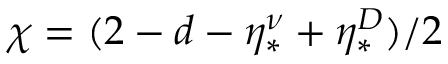Convert formula to latex. <formula><loc_0><loc_0><loc_500><loc_500>\chi = ( 2 - d - \eta _ { * } ^ { \nu } + \eta _ { * } ^ { D } ) / 2</formula> 